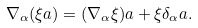<formula> <loc_0><loc_0><loc_500><loc_500>\nabla _ { \alpha } ( \xi a ) = ( \nabla _ { \alpha } \xi ) a + \xi \delta _ { \alpha } a .</formula> 